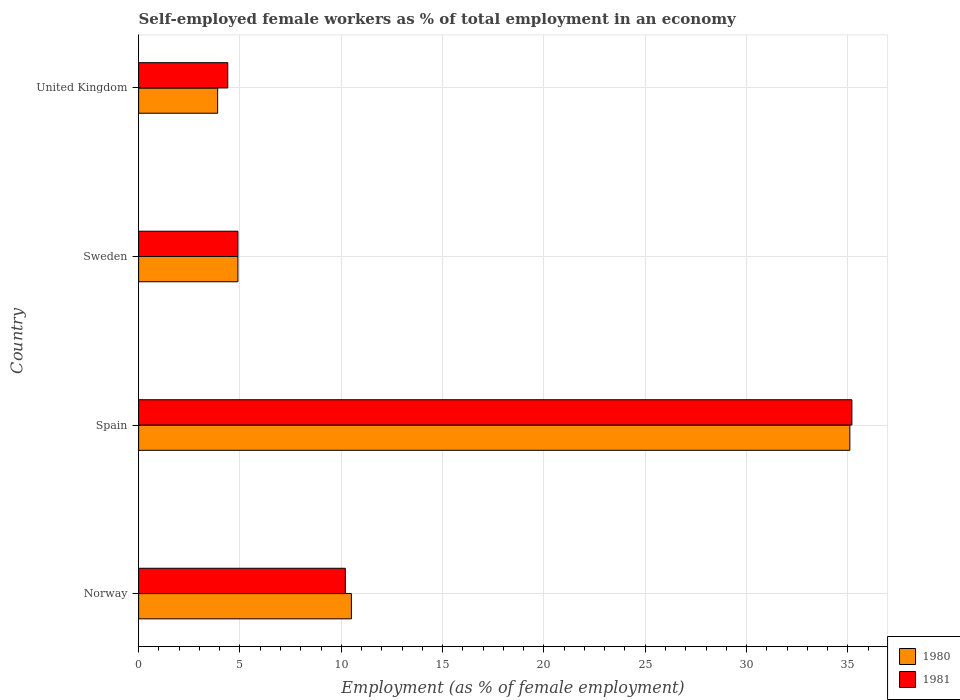Are the number of bars per tick equal to the number of legend labels?
Make the answer very short. Yes. Are the number of bars on each tick of the Y-axis equal?
Provide a succinct answer. Yes. How many bars are there on the 4th tick from the top?
Your answer should be very brief. 2. How many bars are there on the 2nd tick from the bottom?
Your answer should be very brief. 2. In how many cases, is the number of bars for a given country not equal to the number of legend labels?
Your answer should be very brief. 0. What is the percentage of self-employed female workers in 1980 in Spain?
Your answer should be compact. 35.1. Across all countries, what is the maximum percentage of self-employed female workers in 1980?
Offer a very short reply. 35.1. Across all countries, what is the minimum percentage of self-employed female workers in 1980?
Offer a terse response. 3.9. In which country was the percentage of self-employed female workers in 1981 minimum?
Ensure brevity in your answer.  United Kingdom. What is the total percentage of self-employed female workers in 1980 in the graph?
Offer a terse response. 54.4. What is the difference between the percentage of self-employed female workers in 1981 in Norway and that in United Kingdom?
Your response must be concise. 5.8. What is the difference between the percentage of self-employed female workers in 1981 in Norway and the percentage of self-employed female workers in 1980 in United Kingdom?
Keep it short and to the point. 6.3. What is the average percentage of self-employed female workers in 1981 per country?
Ensure brevity in your answer.  13.68. In how many countries, is the percentage of self-employed female workers in 1981 greater than 29 %?
Provide a succinct answer. 1. What is the ratio of the percentage of self-employed female workers in 1981 in Spain to that in United Kingdom?
Your response must be concise. 8. Is the percentage of self-employed female workers in 1981 in Norway less than that in Spain?
Offer a very short reply. Yes. What is the difference between the highest and the second highest percentage of self-employed female workers in 1980?
Give a very brief answer. 24.6. What is the difference between the highest and the lowest percentage of self-employed female workers in 1980?
Give a very brief answer. 31.2. In how many countries, is the percentage of self-employed female workers in 1981 greater than the average percentage of self-employed female workers in 1981 taken over all countries?
Provide a succinct answer. 1. Is the sum of the percentage of self-employed female workers in 1980 in Norway and Sweden greater than the maximum percentage of self-employed female workers in 1981 across all countries?
Offer a very short reply. No. What does the 2nd bar from the top in Sweden represents?
Offer a terse response. 1980. How many bars are there?
Your answer should be compact. 8. Are all the bars in the graph horizontal?
Offer a terse response. Yes. What is the difference between two consecutive major ticks on the X-axis?
Ensure brevity in your answer.  5. Does the graph contain any zero values?
Provide a short and direct response. No. Does the graph contain grids?
Offer a very short reply. Yes. Where does the legend appear in the graph?
Provide a short and direct response. Bottom right. How are the legend labels stacked?
Your answer should be very brief. Vertical. What is the title of the graph?
Your answer should be very brief. Self-employed female workers as % of total employment in an economy. What is the label or title of the X-axis?
Your answer should be very brief. Employment (as % of female employment). What is the Employment (as % of female employment) in 1980 in Norway?
Your answer should be very brief. 10.5. What is the Employment (as % of female employment) in 1981 in Norway?
Keep it short and to the point. 10.2. What is the Employment (as % of female employment) of 1980 in Spain?
Your answer should be compact. 35.1. What is the Employment (as % of female employment) of 1981 in Spain?
Offer a terse response. 35.2. What is the Employment (as % of female employment) in 1980 in Sweden?
Your answer should be compact. 4.9. What is the Employment (as % of female employment) in 1981 in Sweden?
Offer a terse response. 4.9. What is the Employment (as % of female employment) of 1980 in United Kingdom?
Keep it short and to the point. 3.9. What is the Employment (as % of female employment) in 1981 in United Kingdom?
Your response must be concise. 4.4. Across all countries, what is the maximum Employment (as % of female employment) in 1980?
Keep it short and to the point. 35.1. Across all countries, what is the maximum Employment (as % of female employment) in 1981?
Your response must be concise. 35.2. Across all countries, what is the minimum Employment (as % of female employment) in 1980?
Keep it short and to the point. 3.9. Across all countries, what is the minimum Employment (as % of female employment) in 1981?
Your response must be concise. 4.4. What is the total Employment (as % of female employment) of 1980 in the graph?
Ensure brevity in your answer.  54.4. What is the total Employment (as % of female employment) of 1981 in the graph?
Your response must be concise. 54.7. What is the difference between the Employment (as % of female employment) in 1980 in Norway and that in Spain?
Your answer should be compact. -24.6. What is the difference between the Employment (as % of female employment) of 1981 in Norway and that in Spain?
Keep it short and to the point. -25. What is the difference between the Employment (as % of female employment) in 1980 in Norway and that in Sweden?
Keep it short and to the point. 5.6. What is the difference between the Employment (as % of female employment) of 1981 in Norway and that in United Kingdom?
Your answer should be compact. 5.8. What is the difference between the Employment (as % of female employment) of 1980 in Spain and that in Sweden?
Offer a very short reply. 30.2. What is the difference between the Employment (as % of female employment) in 1981 in Spain and that in Sweden?
Provide a short and direct response. 30.3. What is the difference between the Employment (as % of female employment) of 1980 in Spain and that in United Kingdom?
Your response must be concise. 31.2. What is the difference between the Employment (as % of female employment) of 1981 in Spain and that in United Kingdom?
Your response must be concise. 30.8. What is the difference between the Employment (as % of female employment) in 1980 in Sweden and that in United Kingdom?
Make the answer very short. 1. What is the difference between the Employment (as % of female employment) in 1981 in Sweden and that in United Kingdom?
Your answer should be very brief. 0.5. What is the difference between the Employment (as % of female employment) in 1980 in Norway and the Employment (as % of female employment) in 1981 in Spain?
Provide a short and direct response. -24.7. What is the difference between the Employment (as % of female employment) in 1980 in Norway and the Employment (as % of female employment) in 1981 in Sweden?
Provide a short and direct response. 5.6. What is the difference between the Employment (as % of female employment) of 1980 in Norway and the Employment (as % of female employment) of 1981 in United Kingdom?
Offer a terse response. 6.1. What is the difference between the Employment (as % of female employment) of 1980 in Spain and the Employment (as % of female employment) of 1981 in Sweden?
Offer a very short reply. 30.2. What is the difference between the Employment (as % of female employment) of 1980 in Spain and the Employment (as % of female employment) of 1981 in United Kingdom?
Offer a terse response. 30.7. What is the difference between the Employment (as % of female employment) of 1980 in Sweden and the Employment (as % of female employment) of 1981 in United Kingdom?
Your answer should be compact. 0.5. What is the average Employment (as % of female employment) of 1981 per country?
Your response must be concise. 13.68. What is the difference between the Employment (as % of female employment) in 1980 and Employment (as % of female employment) in 1981 in United Kingdom?
Make the answer very short. -0.5. What is the ratio of the Employment (as % of female employment) in 1980 in Norway to that in Spain?
Ensure brevity in your answer.  0.3. What is the ratio of the Employment (as % of female employment) of 1981 in Norway to that in Spain?
Offer a terse response. 0.29. What is the ratio of the Employment (as % of female employment) in 1980 in Norway to that in Sweden?
Provide a succinct answer. 2.14. What is the ratio of the Employment (as % of female employment) of 1981 in Norway to that in Sweden?
Your answer should be very brief. 2.08. What is the ratio of the Employment (as % of female employment) in 1980 in Norway to that in United Kingdom?
Offer a very short reply. 2.69. What is the ratio of the Employment (as % of female employment) of 1981 in Norway to that in United Kingdom?
Your answer should be compact. 2.32. What is the ratio of the Employment (as % of female employment) in 1980 in Spain to that in Sweden?
Give a very brief answer. 7.16. What is the ratio of the Employment (as % of female employment) of 1981 in Spain to that in Sweden?
Offer a very short reply. 7.18. What is the ratio of the Employment (as % of female employment) of 1980 in Spain to that in United Kingdom?
Keep it short and to the point. 9. What is the ratio of the Employment (as % of female employment) of 1981 in Spain to that in United Kingdom?
Ensure brevity in your answer.  8. What is the ratio of the Employment (as % of female employment) of 1980 in Sweden to that in United Kingdom?
Make the answer very short. 1.26. What is the ratio of the Employment (as % of female employment) of 1981 in Sweden to that in United Kingdom?
Provide a succinct answer. 1.11. What is the difference between the highest and the second highest Employment (as % of female employment) of 1980?
Your answer should be very brief. 24.6. What is the difference between the highest and the second highest Employment (as % of female employment) in 1981?
Your answer should be very brief. 25. What is the difference between the highest and the lowest Employment (as % of female employment) of 1980?
Give a very brief answer. 31.2. What is the difference between the highest and the lowest Employment (as % of female employment) of 1981?
Your answer should be compact. 30.8. 